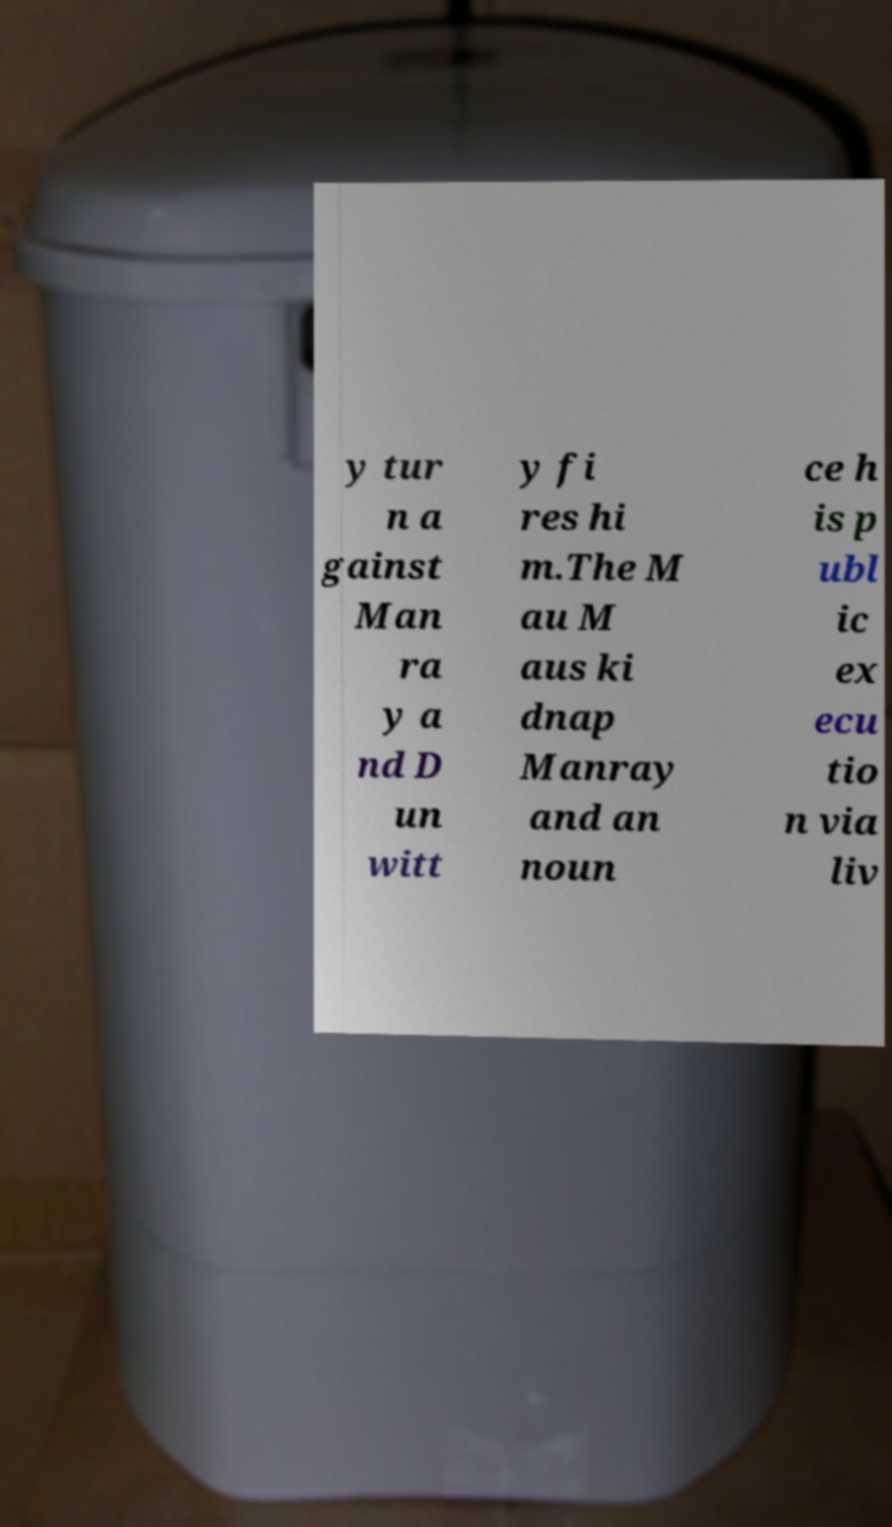Can you accurately transcribe the text from the provided image for me? y tur n a gainst Man ra y a nd D un witt y fi res hi m.The M au M aus ki dnap Manray and an noun ce h is p ubl ic ex ecu tio n via liv 